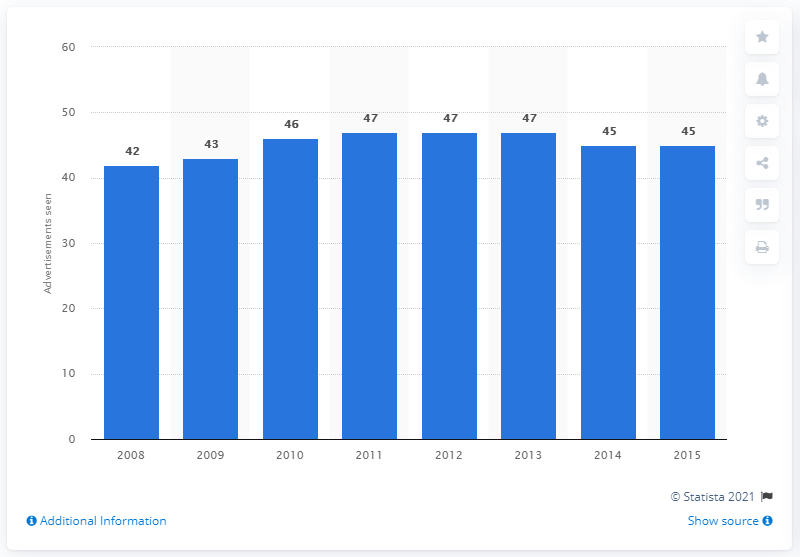Draw attention to some important aspects in this diagram. In 2012, an average of 47 television commercials were viewed per day in the UK. 